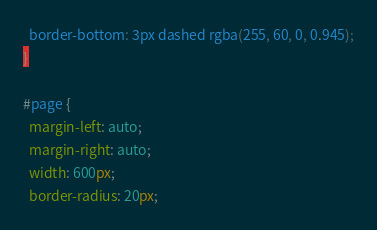<code> <loc_0><loc_0><loc_500><loc_500><_CSS_>  border-bottom: 3px dashed rgba(255, 60, 0, 0.945);
}

#page {
  margin-left: auto;
  margin-right: auto;
  width: 600px;
  border-radius: 20px;</code> 